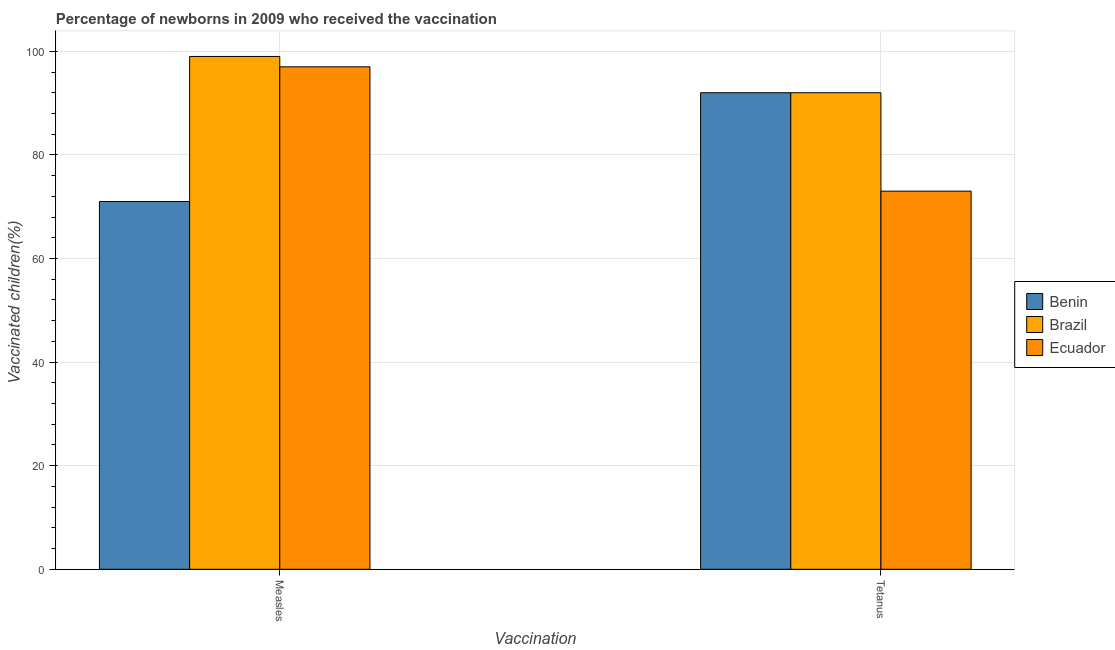How many different coloured bars are there?
Keep it short and to the point. 3. How many groups of bars are there?
Keep it short and to the point. 2. Are the number of bars per tick equal to the number of legend labels?
Your response must be concise. Yes. Are the number of bars on each tick of the X-axis equal?
Offer a terse response. Yes. What is the label of the 1st group of bars from the left?
Offer a terse response. Measles. What is the percentage of newborns who received vaccination for tetanus in Benin?
Make the answer very short. 92. Across all countries, what is the maximum percentage of newborns who received vaccination for tetanus?
Provide a short and direct response. 92. Across all countries, what is the minimum percentage of newborns who received vaccination for measles?
Make the answer very short. 71. In which country was the percentage of newborns who received vaccination for tetanus maximum?
Give a very brief answer. Benin. In which country was the percentage of newborns who received vaccination for tetanus minimum?
Offer a terse response. Ecuador. What is the total percentage of newborns who received vaccination for tetanus in the graph?
Offer a terse response. 257. What is the difference between the percentage of newborns who received vaccination for measles in Benin and that in Ecuador?
Give a very brief answer. -26. What is the difference between the percentage of newborns who received vaccination for measles in Ecuador and the percentage of newborns who received vaccination for tetanus in Brazil?
Provide a succinct answer. 5. What is the average percentage of newborns who received vaccination for tetanus per country?
Your answer should be very brief. 85.67. What is the difference between the percentage of newborns who received vaccination for tetanus and percentage of newborns who received vaccination for measles in Benin?
Offer a very short reply. 21. What is the ratio of the percentage of newborns who received vaccination for measles in Brazil to that in Ecuador?
Give a very brief answer. 1.02. In how many countries, is the percentage of newborns who received vaccination for tetanus greater than the average percentage of newborns who received vaccination for tetanus taken over all countries?
Your answer should be compact. 2. What does the 1st bar from the left in Measles represents?
Your answer should be very brief. Benin. What does the 1st bar from the right in Measles represents?
Your answer should be compact. Ecuador. How many bars are there?
Keep it short and to the point. 6. What is the difference between two consecutive major ticks on the Y-axis?
Offer a terse response. 20. Does the graph contain any zero values?
Your response must be concise. No. Does the graph contain grids?
Offer a terse response. Yes. What is the title of the graph?
Offer a very short reply. Percentage of newborns in 2009 who received the vaccination. What is the label or title of the X-axis?
Keep it short and to the point. Vaccination. What is the label or title of the Y-axis?
Ensure brevity in your answer.  Vaccinated children(%)
. What is the Vaccinated children(%)
 of Ecuador in Measles?
Your answer should be very brief. 97. What is the Vaccinated children(%)
 of Benin in Tetanus?
Keep it short and to the point. 92. What is the Vaccinated children(%)
 in Brazil in Tetanus?
Ensure brevity in your answer.  92. What is the Vaccinated children(%)
 in Ecuador in Tetanus?
Offer a very short reply. 73. Across all Vaccination, what is the maximum Vaccinated children(%)
 in Benin?
Your response must be concise. 92. Across all Vaccination, what is the maximum Vaccinated children(%)
 in Ecuador?
Offer a terse response. 97. Across all Vaccination, what is the minimum Vaccinated children(%)
 of Benin?
Offer a terse response. 71. Across all Vaccination, what is the minimum Vaccinated children(%)
 of Brazil?
Offer a very short reply. 92. What is the total Vaccinated children(%)
 in Benin in the graph?
Make the answer very short. 163. What is the total Vaccinated children(%)
 in Brazil in the graph?
Your response must be concise. 191. What is the total Vaccinated children(%)
 in Ecuador in the graph?
Give a very brief answer. 170. What is the difference between the Vaccinated children(%)
 of Brazil in Measles and that in Tetanus?
Your answer should be compact. 7. What is the difference between the Vaccinated children(%)
 in Ecuador in Measles and that in Tetanus?
Keep it short and to the point. 24. What is the difference between the Vaccinated children(%)
 in Benin in Measles and the Vaccinated children(%)
 in Brazil in Tetanus?
Provide a short and direct response. -21. What is the difference between the Vaccinated children(%)
 of Benin in Measles and the Vaccinated children(%)
 of Ecuador in Tetanus?
Provide a short and direct response. -2. What is the difference between the Vaccinated children(%)
 in Brazil in Measles and the Vaccinated children(%)
 in Ecuador in Tetanus?
Provide a short and direct response. 26. What is the average Vaccinated children(%)
 in Benin per Vaccination?
Offer a very short reply. 81.5. What is the average Vaccinated children(%)
 of Brazil per Vaccination?
Give a very brief answer. 95.5. What is the average Vaccinated children(%)
 in Ecuador per Vaccination?
Provide a short and direct response. 85. What is the difference between the Vaccinated children(%)
 of Brazil and Vaccinated children(%)
 of Ecuador in Measles?
Your answer should be very brief. 2. What is the difference between the Vaccinated children(%)
 of Benin and Vaccinated children(%)
 of Brazil in Tetanus?
Keep it short and to the point. 0. What is the difference between the Vaccinated children(%)
 in Brazil and Vaccinated children(%)
 in Ecuador in Tetanus?
Your answer should be very brief. 19. What is the ratio of the Vaccinated children(%)
 in Benin in Measles to that in Tetanus?
Offer a very short reply. 0.77. What is the ratio of the Vaccinated children(%)
 of Brazil in Measles to that in Tetanus?
Give a very brief answer. 1.08. What is the ratio of the Vaccinated children(%)
 in Ecuador in Measles to that in Tetanus?
Your response must be concise. 1.33. What is the difference between the highest and the second highest Vaccinated children(%)
 of Brazil?
Offer a very short reply. 7. What is the difference between the highest and the second highest Vaccinated children(%)
 in Ecuador?
Offer a very short reply. 24. What is the difference between the highest and the lowest Vaccinated children(%)
 of Benin?
Your answer should be compact. 21. What is the difference between the highest and the lowest Vaccinated children(%)
 in Ecuador?
Your answer should be very brief. 24. 